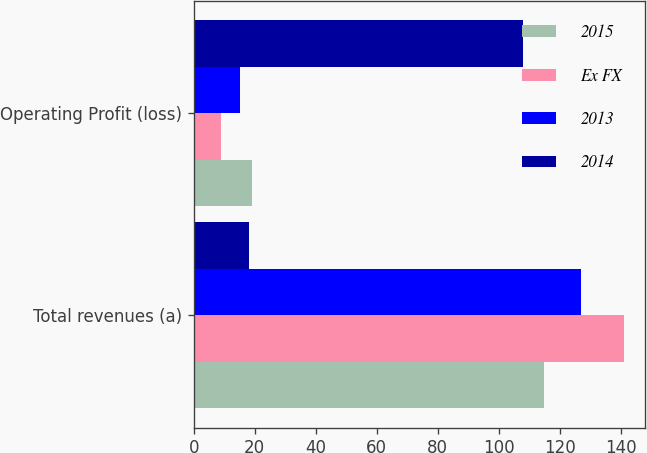Convert chart to OTSL. <chart><loc_0><loc_0><loc_500><loc_500><stacked_bar_chart><ecel><fcel>Total revenues (a)<fcel>Operating Profit (loss)<nl><fcel>2015<fcel>115<fcel>19<nl><fcel>Ex FX<fcel>141<fcel>9<nl><fcel>2013<fcel>127<fcel>15<nl><fcel>2014<fcel>18<fcel>108<nl></chart> 